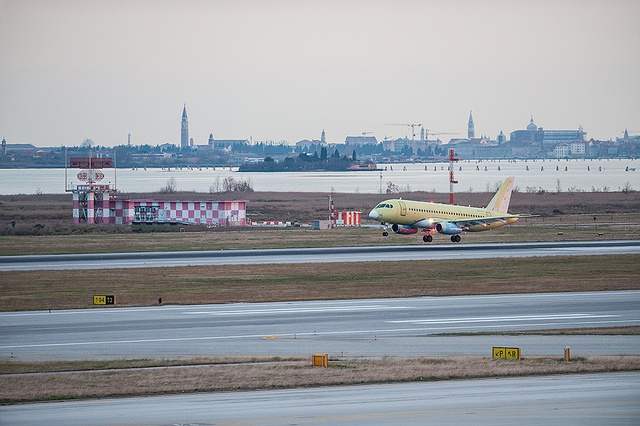Describe the objects in this image and their specific colors. I can see a airplane in darkgray, beige, gray, and tan tones in this image. 